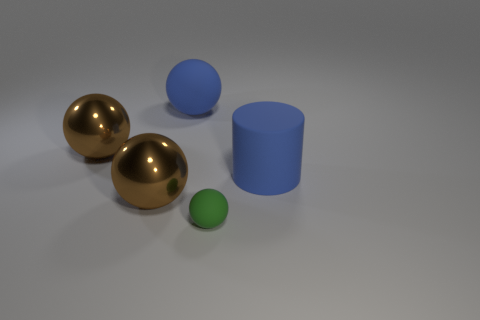What textures are present on the surfaces of the objects? The surfaces of the two larger spheres exhibit a reflective, likely metallic texture, while the cylinder has a smooth surface that is also reflective but less so than the spheres. The small green sphere has a matte texture that does not reflect the environment. 